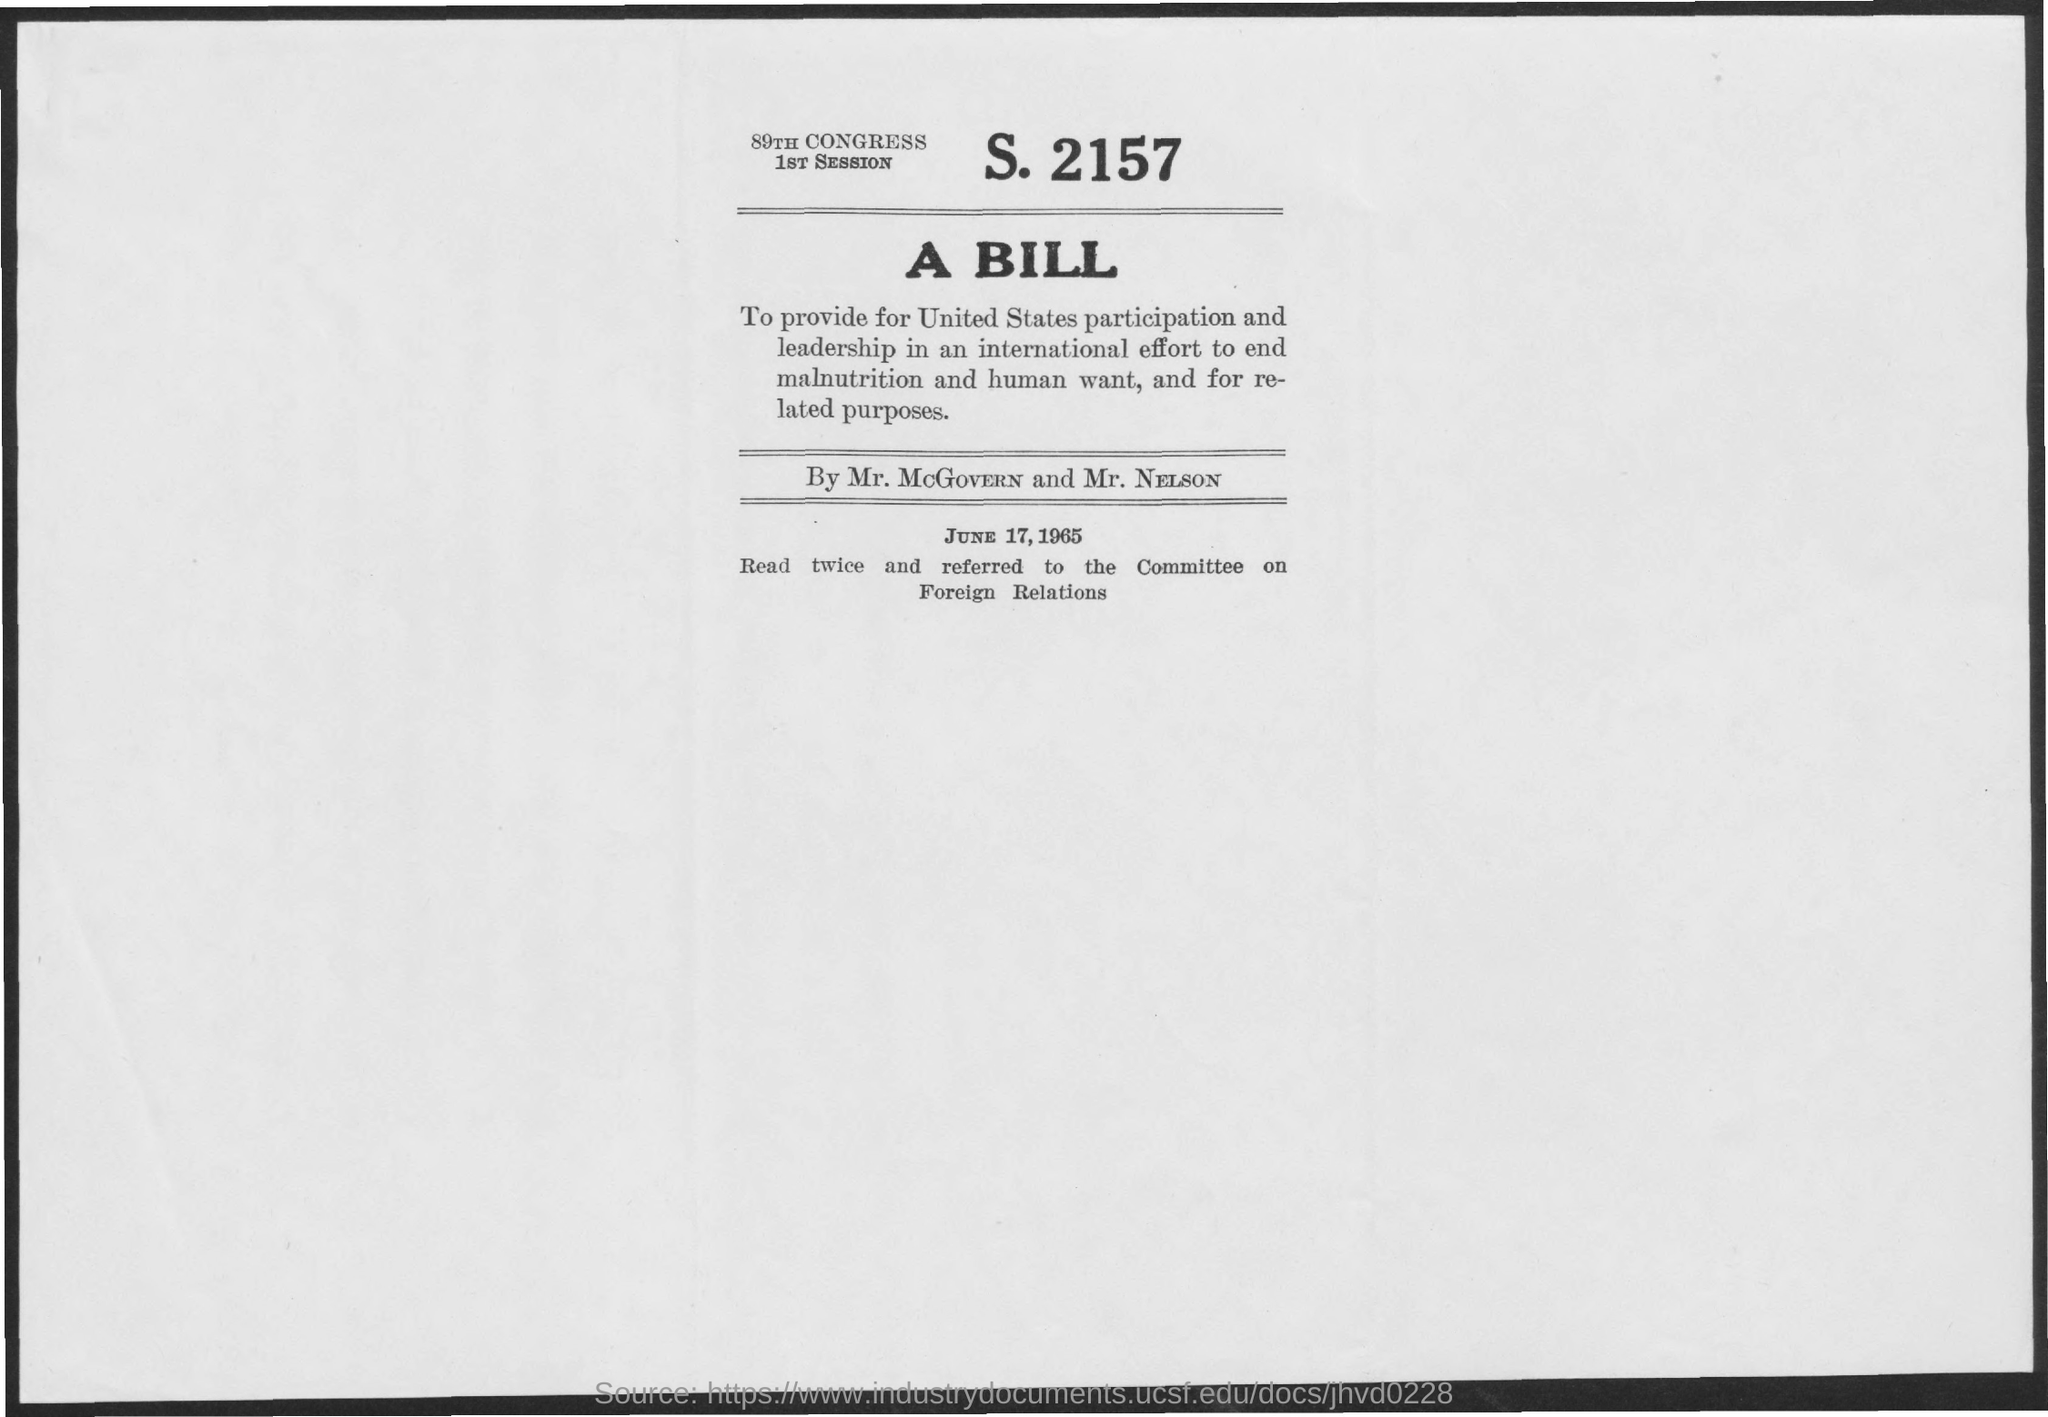What is the date mentioned in the document?
Offer a terse response. June 17,1965. 